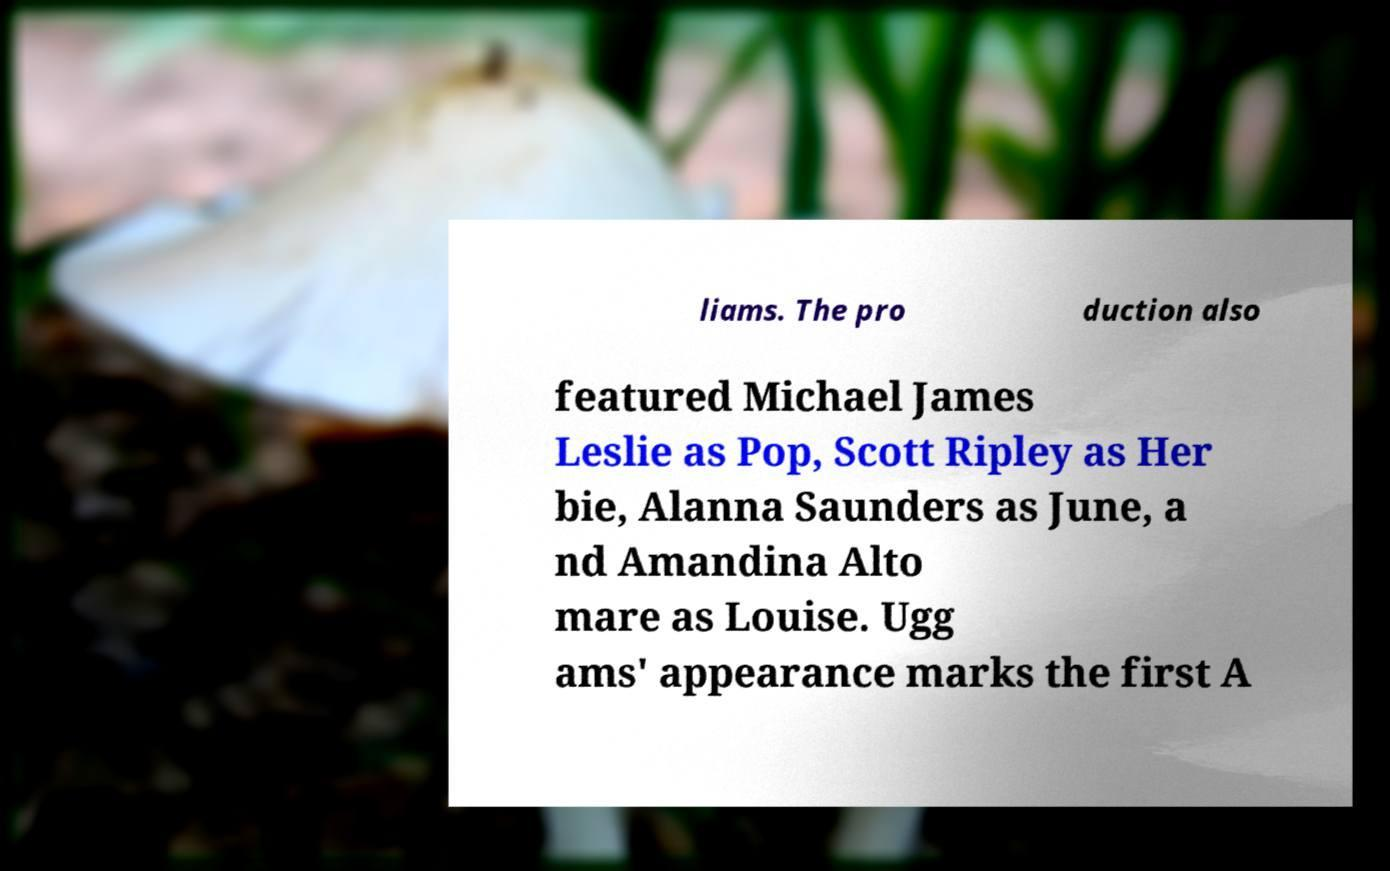For documentation purposes, I need the text within this image transcribed. Could you provide that? liams. The pro duction also featured Michael James Leslie as Pop, Scott Ripley as Her bie, Alanna Saunders as June, a nd Amandina Alto mare as Louise. Ugg ams' appearance marks the first A 